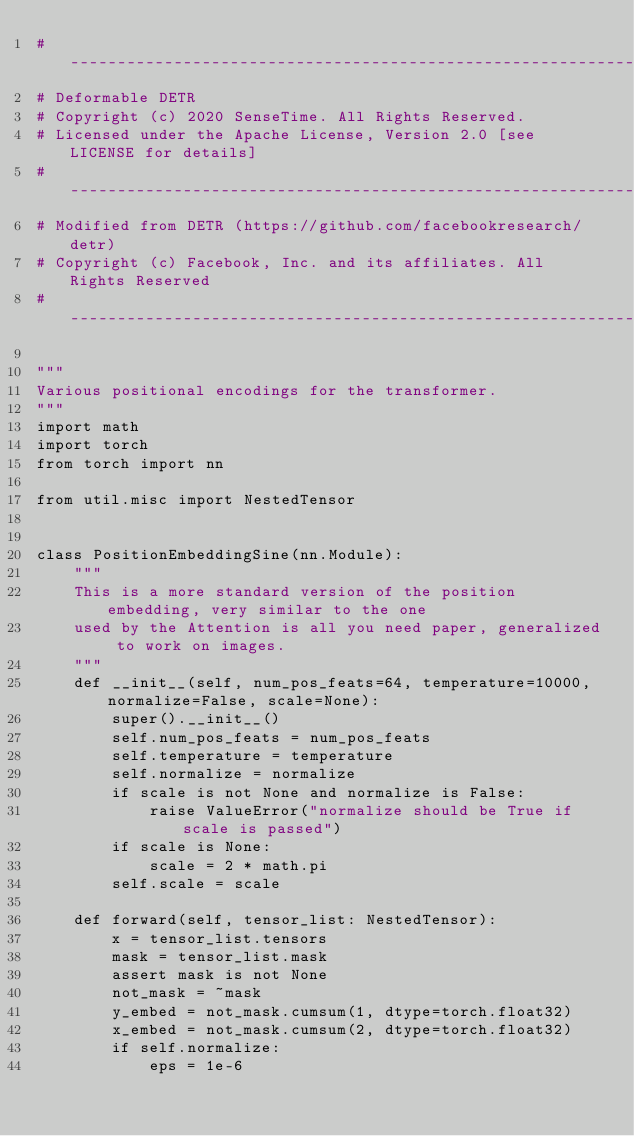Convert code to text. <code><loc_0><loc_0><loc_500><loc_500><_Python_># ------------------------------------------------------------------------
# Deformable DETR
# Copyright (c) 2020 SenseTime. All Rights Reserved.
# Licensed under the Apache License, Version 2.0 [see LICENSE for details]
# ------------------------------------------------------------------------
# Modified from DETR (https://github.com/facebookresearch/detr)
# Copyright (c) Facebook, Inc. and its affiliates. All Rights Reserved
# ------------------------------------------------------------------------

"""
Various positional encodings for the transformer.
"""
import math
import torch
from torch import nn

from util.misc import NestedTensor


class PositionEmbeddingSine(nn.Module):
    """
    This is a more standard version of the position embedding, very similar to the one
    used by the Attention is all you need paper, generalized to work on images.
    """
    def __init__(self, num_pos_feats=64, temperature=10000, normalize=False, scale=None):
        super().__init__()
        self.num_pos_feats = num_pos_feats
        self.temperature = temperature
        self.normalize = normalize
        if scale is not None and normalize is False:
            raise ValueError("normalize should be True if scale is passed")
        if scale is None:
            scale = 2 * math.pi
        self.scale = scale

    def forward(self, tensor_list: NestedTensor):
        x = tensor_list.tensors
        mask = tensor_list.mask
        assert mask is not None
        not_mask = ~mask
        y_embed = not_mask.cumsum(1, dtype=torch.float32)
        x_embed = not_mask.cumsum(2, dtype=torch.float32)
        if self.normalize:
            eps = 1e-6</code> 